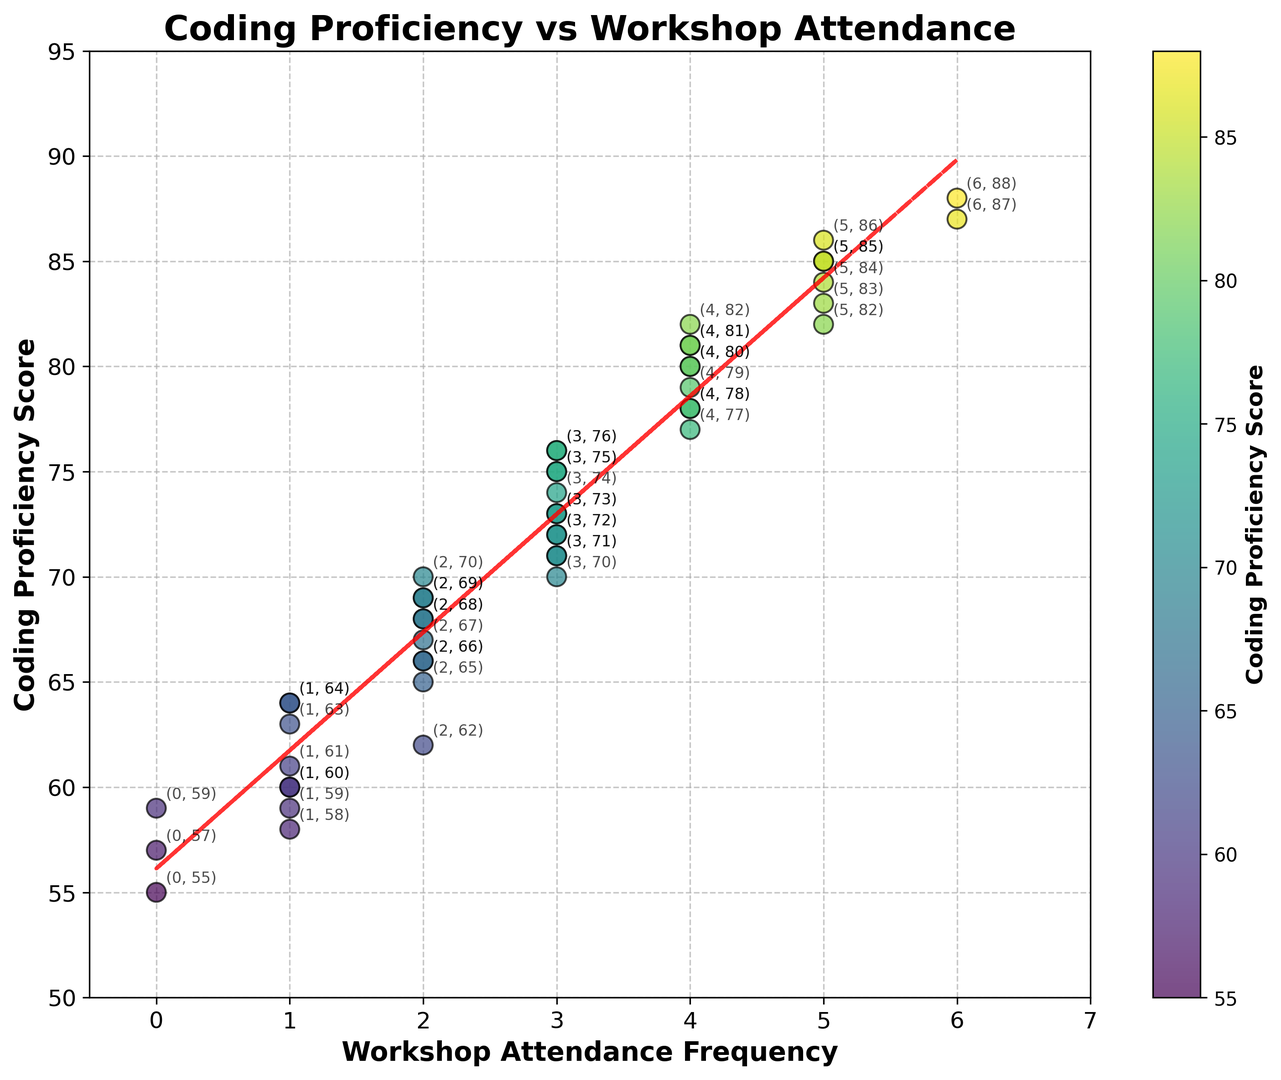What's the maximum coding proficiency score observed in the plot? To find the maximum coding proficiency score, look at the highest point on the vertical (Y) axis. The highest score is 88.
Answer: 88 What's the most frequent workshop attendance level? To determine the most frequent workshop attendance level, observe the horizontal (X) positions of the scatter points. The number 3 appears most frequently.
Answer: 3 Is there a positive correlation between workshop attendance frequency and coding proficiency scores? To determine if there's a positive correlation, look at the line of best fit in the scatter plot. Since the line slopes upwards, it indicates a positive correlation.
Answer: Yes What's the coding proficiency score when the workshop attendance frequency is 2? Look at the points along the vertical line where the X-axis value is 2. The scores are 65, 62, 68, and 66.
Answer: 65, 62, 68, 66 What's the coding proficiency score when no workshops have been attended? Identify the point along the vertical line where the X-axis value is 0. The score is 55.
Answer: 55 How does the coding proficiency score compare between students who attended 2 workshops and 5 workshops? Examine the points at X=2 and X=5. For X=2, the scores are 65, 62, 68, and 66. For X=5, the scores are 85, 82, and 84. This shows that students who attended 5 workshops generally have higher scores.
Answer: Students who attended 5 workshops have higher scores What's the average coding proficiency score for students who attended 3 workshops? Add the scores for students who attended 3 workshops and divide by the number of such students. Scores are 72, 75, 70, 73, 71, 76, 74 = (72 + 75 + 70 + 73 + 71 + 76 + 74) / 7 = 511 / 7 = 73
Answer: 73 What is the coding proficiency score range for students who attended 4 workshops? Identify the points at X=4 to find the minimum and maximum Y-values. For X=4, the scores are 80, 78, 77, 79, 82, 81 = range is max(82) - min(77) = 82 - 77 = 5
Answer: 5 How many students attended more than 3 workshops? Count the number of points to the right of X=3. There are 5 points each for X=4 and X=5, and 2 points for X=6, totaling 12 students.
Answer: 12 Do any students have a proficiency score of 60, and if so, how many workshops did they attend? Identify points with a Y-value of 60. There are points at (1, 60) and (1, 60), indicating these students attended 1 workshop each.
Answer: 1 workshop 